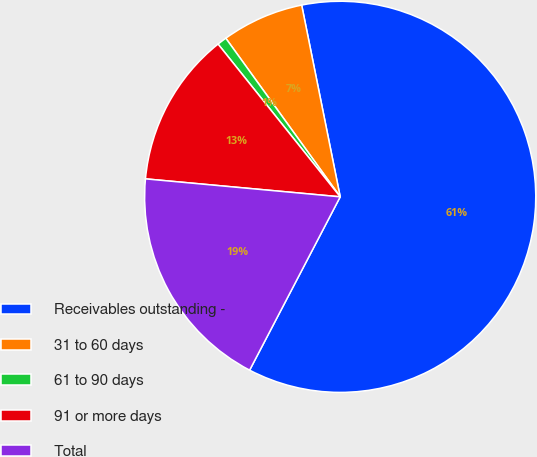Convert chart. <chart><loc_0><loc_0><loc_500><loc_500><pie_chart><fcel>Receivables outstanding -<fcel>31 to 60 days<fcel>61 to 90 days<fcel>91 or more days<fcel>Total<nl><fcel>60.82%<fcel>6.79%<fcel>0.79%<fcel>12.8%<fcel>18.8%<nl></chart> 